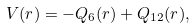<formula> <loc_0><loc_0><loc_500><loc_500>V ( r ) = - Q _ { 6 } ( r ) + Q _ { 1 2 } ( r ) ,</formula> 